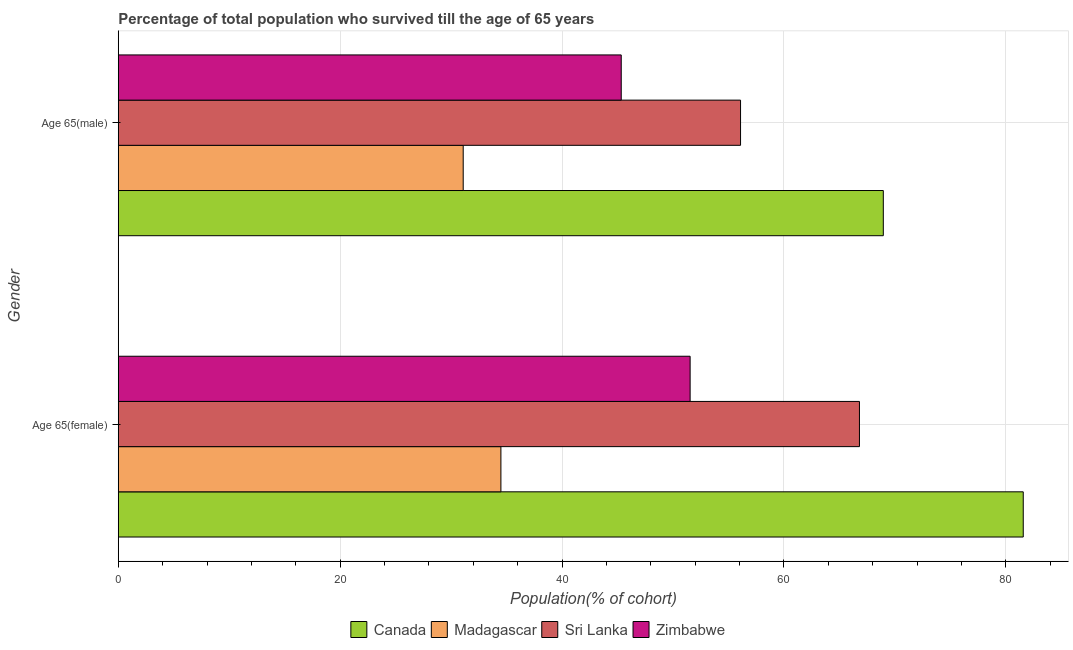How many groups of bars are there?
Keep it short and to the point. 2. Are the number of bars per tick equal to the number of legend labels?
Ensure brevity in your answer.  Yes. How many bars are there on the 2nd tick from the top?
Make the answer very short. 4. How many bars are there on the 2nd tick from the bottom?
Give a very brief answer. 4. What is the label of the 2nd group of bars from the top?
Provide a short and direct response. Age 65(female). What is the percentage of male population who survived till age of 65 in Canada?
Provide a succinct answer. 68.96. Across all countries, what is the maximum percentage of male population who survived till age of 65?
Provide a succinct answer. 68.96. Across all countries, what is the minimum percentage of male population who survived till age of 65?
Your response must be concise. 31.09. In which country was the percentage of female population who survived till age of 65 maximum?
Offer a terse response. Canada. In which country was the percentage of male population who survived till age of 65 minimum?
Make the answer very short. Madagascar. What is the total percentage of male population who survived till age of 65 in the graph?
Your response must be concise. 201.48. What is the difference between the percentage of female population who survived till age of 65 in Madagascar and that in Canada?
Provide a succinct answer. -47.08. What is the difference between the percentage of male population who survived till age of 65 in Madagascar and the percentage of female population who survived till age of 65 in Zimbabwe?
Ensure brevity in your answer.  -20.45. What is the average percentage of female population who survived till age of 65 per country?
Your answer should be very brief. 58.61. What is the difference between the percentage of female population who survived till age of 65 and percentage of male population who survived till age of 65 in Canada?
Offer a terse response. 12.61. In how many countries, is the percentage of male population who survived till age of 65 greater than 36 %?
Keep it short and to the point. 3. What is the ratio of the percentage of female population who survived till age of 65 in Sri Lanka to that in Canada?
Offer a terse response. 0.82. In how many countries, is the percentage of female population who survived till age of 65 greater than the average percentage of female population who survived till age of 65 taken over all countries?
Your answer should be very brief. 2. What does the 3rd bar from the top in Age 65(male) represents?
Your answer should be compact. Madagascar. How many bars are there?
Provide a succinct answer. 8. How many countries are there in the graph?
Your response must be concise. 4. Are the values on the major ticks of X-axis written in scientific E-notation?
Offer a terse response. No. Does the graph contain grids?
Offer a very short reply. Yes. Where does the legend appear in the graph?
Provide a succinct answer. Bottom center. How are the legend labels stacked?
Ensure brevity in your answer.  Horizontal. What is the title of the graph?
Offer a terse response. Percentage of total population who survived till the age of 65 years. What is the label or title of the X-axis?
Provide a short and direct response. Population(% of cohort). What is the label or title of the Y-axis?
Provide a short and direct response. Gender. What is the Population(% of cohort) in Canada in Age 65(female)?
Your answer should be compact. 81.57. What is the Population(% of cohort) of Madagascar in Age 65(female)?
Ensure brevity in your answer.  34.49. What is the Population(% of cohort) in Sri Lanka in Age 65(female)?
Your answer should be very brief. 66.81. What is the Population(% of cohort) of Zimbabwe in Age 65(female)?
Make the answer very short. 51.55. What is the Population(% of cohort) in Canada in Age 65(male)?
Your answer should be compact. 68.96. What is the Population(% of cohort) in Madagascar in Age 65(male)?
Offer a terse response. 31.09. What is the Population(% of cohort) in Sri Lanka in Age 65(male)?
Ensure brevity in your answer.  56.09. What is the Population(% of cohort) in Zimbabwe in Age 65(male)?
Offer a terse response. 45.34. Across all Gender, what is the maximum Population(% of cohort) in Canada?
Keep it short and to the point. 81.57. Across all Gender, what is the maximum Population(% of cohort) of Madagascar?
Offer a very short reply. 34.49. Across all Gender, what is the maximum Population(% of cohort) in Sri Lanka?
Keep it short and to the point. 66.81. Across all Gender, what is the maximum Population(% of cohort) of Zimbabwe?
Provide a short and direct response. 51.55. Across all Gender, what is the minimum Population(% of cohort) in Canada?
Give a very brief answer. 68.96. Across all Gender, what is the minimum Population(% of cohort) of Madagascar?
Give a very brief answer. 31.09. Across all Gender, what is the minimum Population(% of cohort) in Sri Lanka?
Ensure brevity in your answer.  56.09. Across all Gender, what is the minimum Population(% of cohort) of Zimbabwe?
Offer a very short reply. 45.34. What is the total Population(% of cohort) in Canada in the graph?
Make the answer very short. 150.54. What is the total Population(% of cohort) in Madagascar in the graph?
Make the answer very short. 65.58. What is the total Population(% of cohort) in Sri Lanka in the graph?
Provide a short and direct response. 122.9. What is the total Population(% of cohort) of Zimbabwe in the graph?
Provide a succinct answer. 96.88. What is the difference between the Population(% of cohort) of Canada in Age 65(female) and that in Age 65(male)?
Provide a short and direct response. 12.61. What is the difference between the Population(% of cohort) of Madagascar in Age 65(female) and that in Age 65(male)?
Offer a very short reply. 3.4. What is the difference between the Population(% of cohort) in Sri Lanka in Age 65(female) and that in Age 65(male)?
Provide a short and direct response. 10.72. What is the difference between the Population(% of cohort) of Zimbabwe in Age 65(female) and that in Age 65(male)?
Offer a terse response. 6.21. What is the difference between the Population(% of cohort) in Canada in Age 65(female) and the Population(% of cohort) in Madagascar in Age 65(male)?
Keep it short and to the point. 50.48. What is the difference between the Population(% of cohort) of Canada in Age 65(female) and the Population(% of cohort) of Sri Lanka in Age 65(male)?
Offer a terse response. 25.48. What is the difference between the Population(% of cohort) in Canada in Age 65(female) and the Population(% of cohort) in Zimbabwe in Age 65(male)?
Your answer should be compact. 36.24. What is the difference between the Population(% of cohort) in Madagascar in Age 65(female) and the Population(% of cohort) in Sri Lanka in Age 65(male)?
Give a very brief answer. -21.6. What is the difference between the Population(% of cohort) of Madagascar in Age 65(female) and the Population(% of cohort) of Zimbabwe in Age 65(male)?
Provide a succinct answer. -10.85. What is the difference between the Population(% of cohort) of Sri Lanka in Age 65(female) and the Population(% of cohort) of Zimbabwe in Age 65(male)?
Your response must be concise. 21.47. What is the average Population(% of cohort) of Canada per Gender?
Ensure brevity in your answer.  75.27. What is the average Population(% of cohort) in Madagascar per Gender?
Offer a very short reply. 32.79. What is the average Population(% of cohort) in Sri Lanka per Gender?
Give a very brief answer. 61.45. What is the average Population(% of cohort) in Zimbabwe per Gender?
Your answer should be compact. 48.44. What is the difference between the Population(% of cohort) of Canada and Population(% of cohort) of Madagascar in Age 65(female)?
Provide a succinct answer. 47.08. What is the difference between the Population(% of cohort) in Canada and Population(% of cohort) in Sri Lanka in Age 65(female)?
Keep it short and to the point. 14.76. What is the difference between the Population(% of cohort) of Canada and Population(% of cohort) of Zimbabwe in Age 65(female)?
Your answer should be very brief. 30.03. What is the difference between the Population(% of cohort) of Madagascar and Population(% of cohort) of Sri Lanka in Age 65(female)?
Offer a very short reply. -32.32. What is the difference between the Population(% of cohort) of Madagascar and Population(% of cohort) of Zimbabwe in Age 65(female)?
Provide a succinct answer. -17.06. What is the difference between the Population(% of cohort) of Sri Lanka and Population(% of cohort) of Zimbabwe in Age 65(female)?
Provide a short and direct response. 15.26. What is the difference between the Population(% of cohort) in Canada and Population(% of cohort) in Madagascar in Age 65(male)?
Offer a very short reply. 37.87. What is the difference between the Population(% of cohort) in Canada and Population(% of cohort) in Sri Lanka in Age 65(male)?
Offer a very short reply. 12.87. What is the difference between the Population(% of cohort) of Canada and Population(% of cohort) of Zimbabwe in Age 65(male)?
Provide a succinct answer. 23.62. What is the difference between the Population(% of cohort) of Madagascar and Population(% of cohort) of Zimbabwe in Age 65(male)?
Your response must be concise. -14.25. What is the difference between the Population(% of cohort) of Sri Lanka and Population(% of cohort) of Zimbabwe in Age 65(male)?
Offer a very short reply. 10.75. What is the ratio of the Population(% of cohort) of Canada in Age 65(female) to that in Age 65(male)?
Make the answer very short. 1.18. What is the ratio of the Population(% of cohort) in Madagascar in Age 65(female) to that in Age 65(male)?
Ensure brevity in your answer.  1.11. What is the ratio of the Population(% of cohort) in Sri Lanka in Age 65(female) to that in Age 65(male)?
Offer a terse response. 1.19. What is the ratio of the Population(% of cohort) of Zimbabwe in Age 65(female) to that in Age 65(male)?
Ensure brevity in your answer.  1.14. What is the difference between the highest and the second highest Population(% of cohort) of Canada?
Your answer should be compact. 12.61. What is the difference between the highest and the second highest Population(% of cohort) in Madagascar?
Provide a short and direct response. 3.4. What is the difference between the highest and the second highest Population(% of cohort) of Sri Lanka?
Offer a terse response. 10.72. What is the difference between the highest and the second highest Population(% of cohort) in Zimbabwe?
Your answer should be compact. 6.21. What is the difference between the highest and the lowest Population(% of cohort) of Canada?
Offer a very short reply. 12.61. What is the difference between the highest and the lowest Population(% of cohort) in Madagascar?
Your response must be concise. 3.4. What is the difference between the highest and the lowest Population(% of cohort) in Sri Lanka?
Your answer should be very brief. 10.72. What is the difference between the highest and the lowest Population(% of cohort) of Zimbabwe?
Provide a succinct answer. 6.21. 